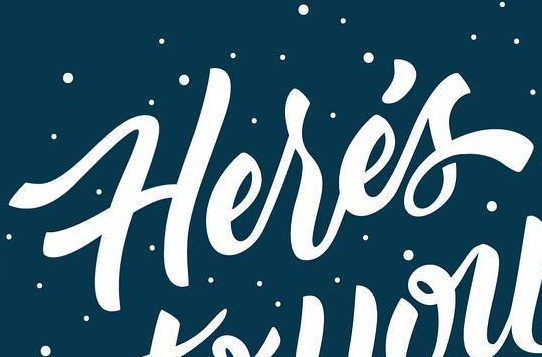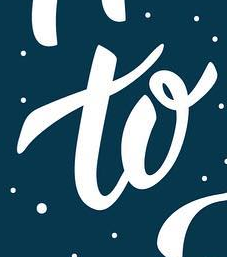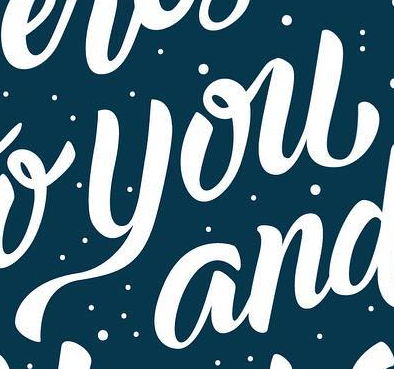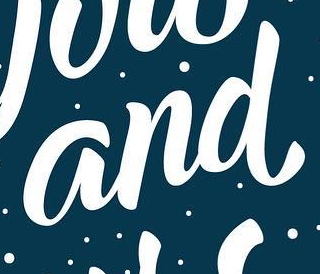Transcribe the words shown in these images in order, separated by a semicolon. Herés; to; you; and 